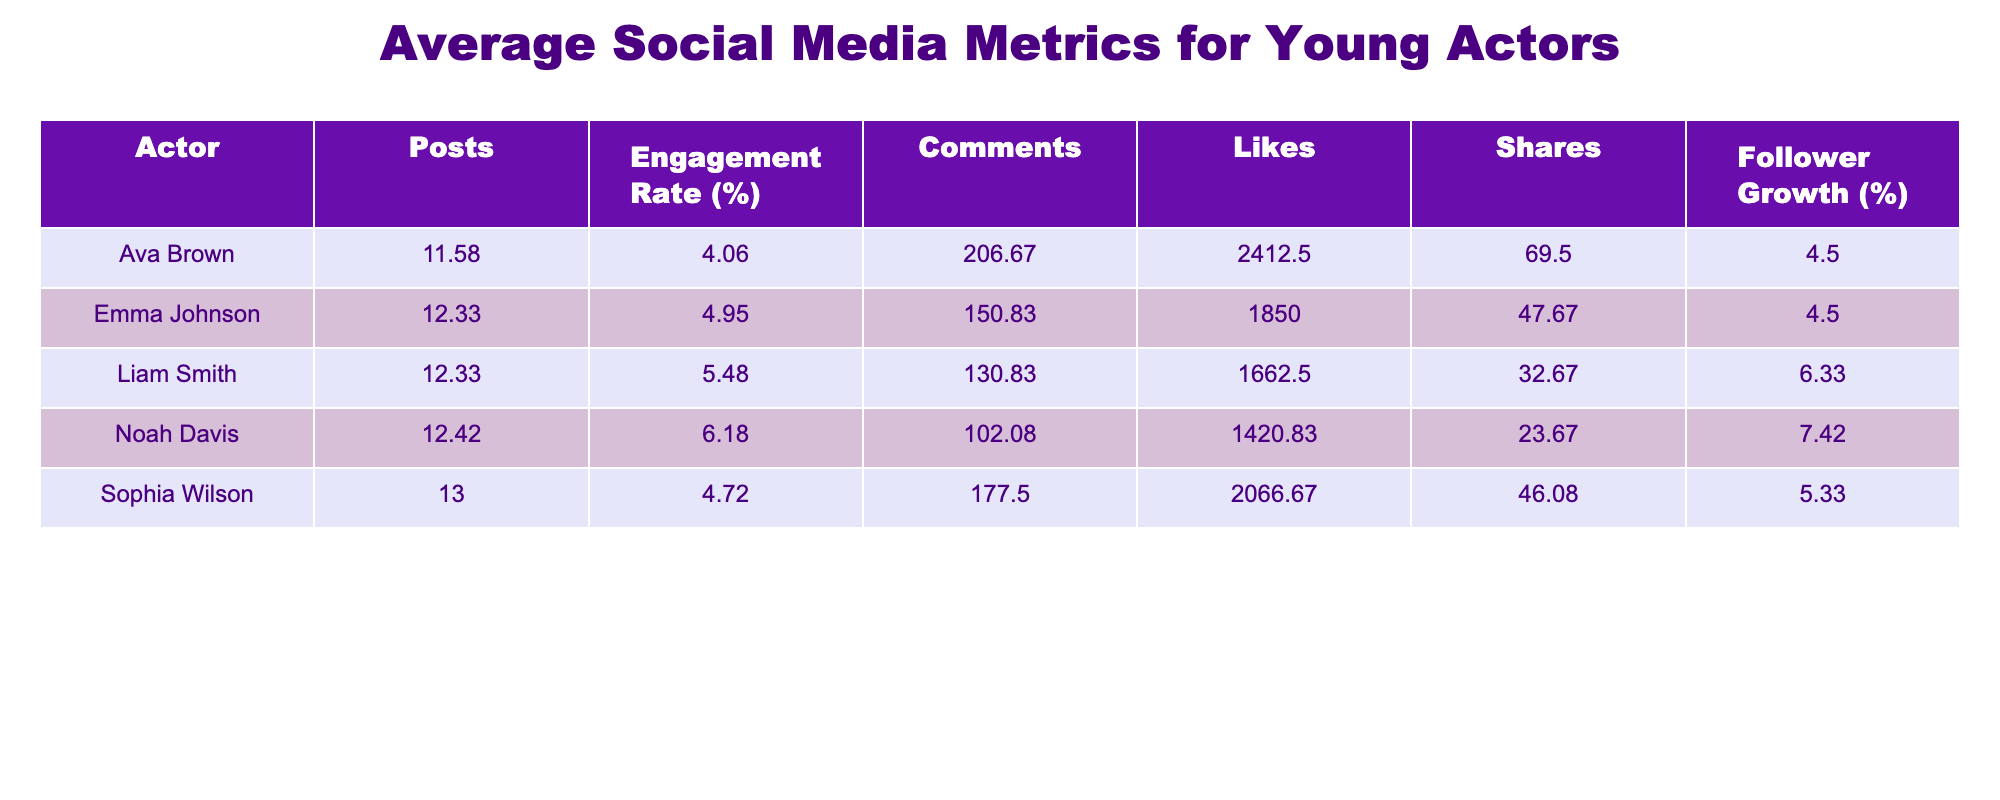What was the highest engagement rate recorded for any actor in a month? By inspecting the engagement rates, Noah Davis had the highest rate of 6.5% in May.
Answer: 6.5% Which actor had the most average likes per post? To find this, we look at the 'Likes' column for each actor and calculate the averages: Emma Johnson (1875), Liam Smith (1687.5), Ava Brown (2362.5), Noah Davis (1450), and Sophia Wilson (2050). Ava Brown has the highest average likes of 2362.5.
Answer: Ava Brown Did Sophia Wilson maintain a consistent engagement rate across the months? We need to compare Sophia Wilson's engagement rates month by month: 4.0, 4.6, 4.7, 4.8, 5.1, 5.0, 4.9, and 4.5. There are fluctuations in her engagement rates indicating inconsistency.
Answer: No Which actor experienced the highest overall follower growth percentage throughout the year? We calculate the average follower growth for each actor. Emma Johnson (4.25), Liam Smith (6.00), Ava Brown (5.00), Noah Davis (6.00), and Sophia Wilson (5.00). Both Liam Smith and Noah Davis have the highest average follower growth of 6.00%.
Answer: Liam Smith and Noah Davis What is the average number of posts made by Emma Johnson over the year? Counting Emma Johnson's posts month-wise: 12, 10, 14, 12, 10, 11, 15, 13, 12, 15, and 10, we find the total is 138. Dividing by 12 months gives us an average of 11.5.
Answer: 11.5 